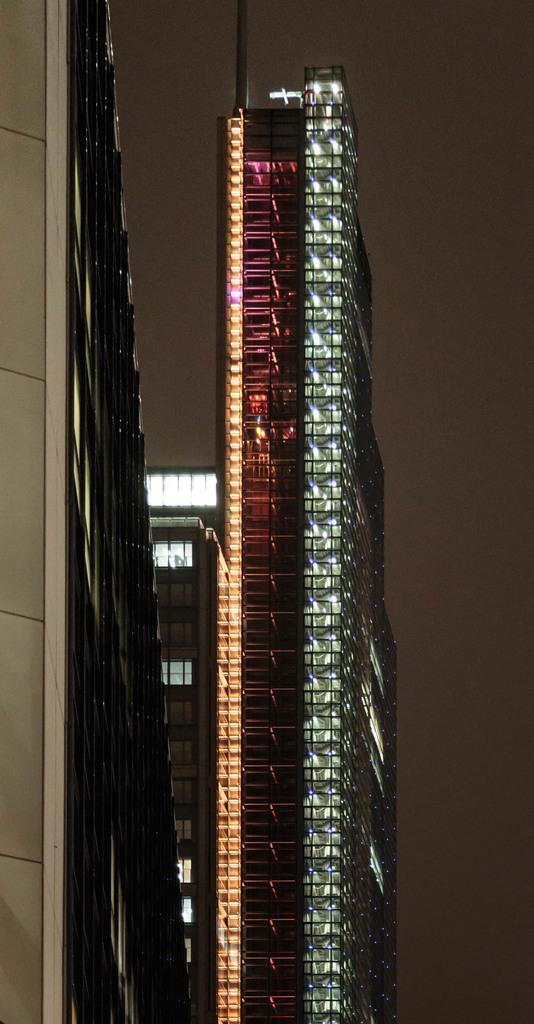What type of structures can be seen in the image? There are buildings in the image. What part of the natural environment is visible in the image? The sky is visible in the background of the image. What type of fowl can be seen flying in the image? There is no fowl visible in the image; it only features buildings and the sky. 